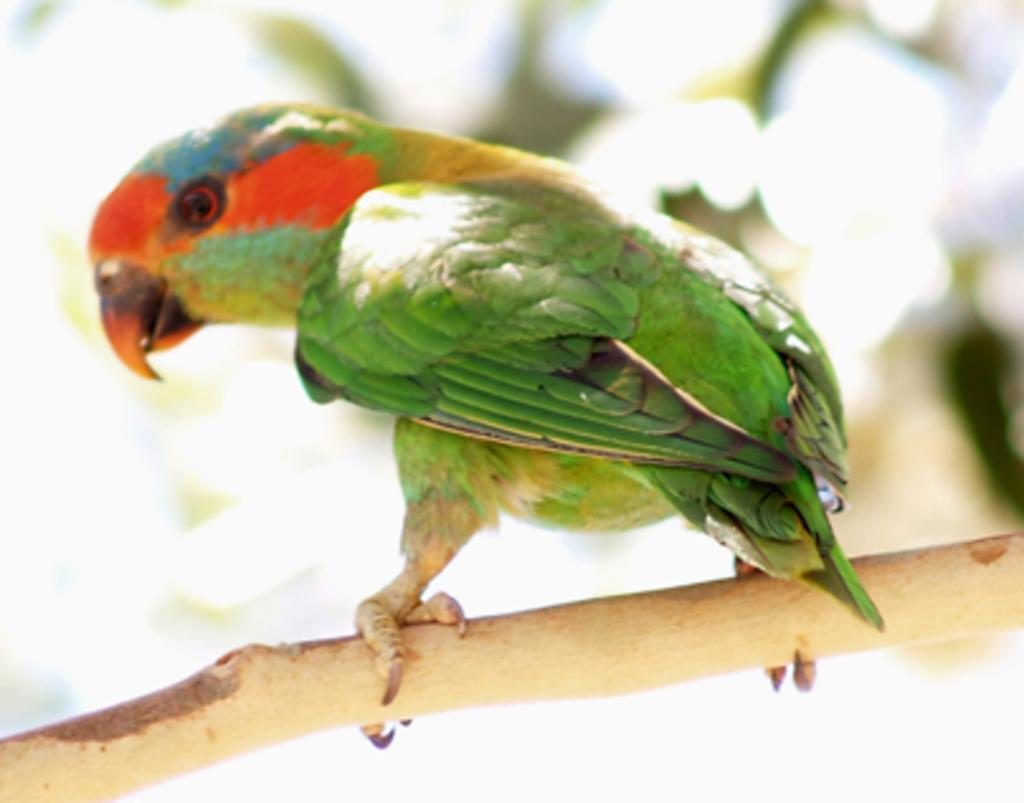What type of animal is in the image? There is a green parrot in the image. Where is the parrot located? The parrot is standing on a tree branch. Can you describe the background of the image? The background of the image is blurred. What is the taste of the jellyfish in the image? There are no jellyfish present in the image, so it is not possible to determine their taste. 